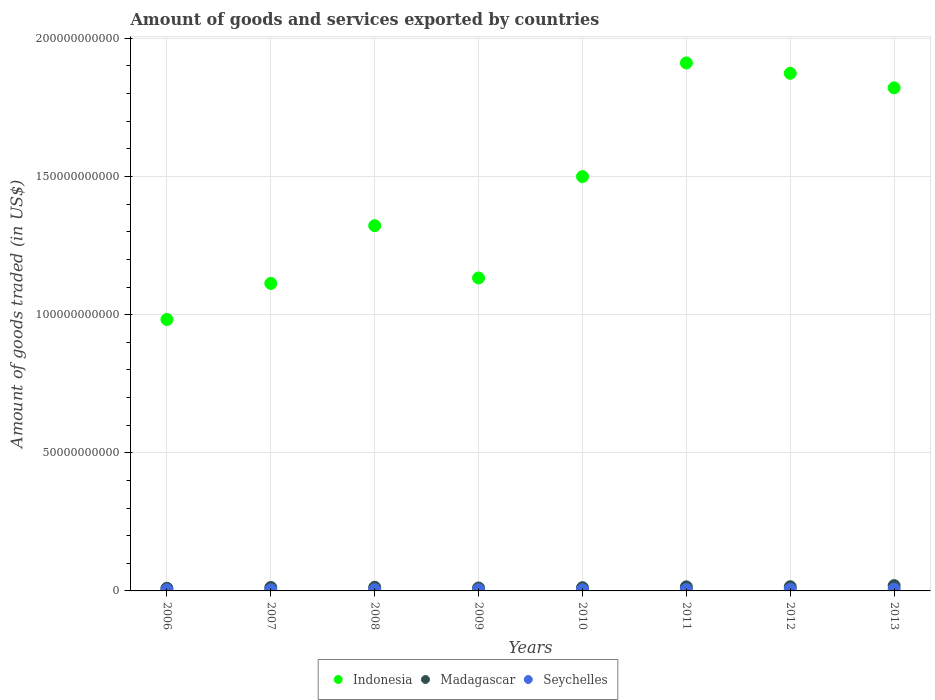How many different coloured dotlines are there?
Your answer should be very brief. 3. Is the number of dotlines equal to the number of legend labels?
Your response must be concise. Yes. What is the total amount of goods and services exported in Seychelles in 2011?
Offer a terse response. 4.77e+08. Across all years, what is the maximum total amount of goods and services exported in Madagascar?
Make the answer very short. 1.92e+09. Across all years, what is the minimum total amount of goods and services exported in Indonesia?
Give a very brief answer. 9.83e+1. In which year was the total amount of goods and services exported in Indonesia maximum?
Offer a terse response. 2011. What is the total total amount of goods and services exported in Madagascar in the graph?
Provide a short and direct response. 1.07e+1. What is the difference between the total amount of goods and services exported in Indonesia in 2007 and that in 2011?
Ensure brevity in your answer.  -7.98e+1. What is the difference between the total amount of goods and services exported in Madagascar in 2013 and the total amount of goods and services exported in Seychelles in 2012?
Provide a succinct answer. 1.36e+09. What is the average total amount of goods and services exported in Seychelles per year?
Provide a short and direct response. 4.69e+08. In the year 2007, what is the difference between the total amount of goods and services exported in Madagascar and total amount of goods and services exported in Indonesia?
Provide a short and direct response. -1.10e+11. What is the ratio of the total amount of goods and services exported in Indonesia in 2009 to that in 2013?
Provide a short and direct response. 0.62. Is the difference between the total amount of goods and services exported in Madagascar in 2006 and 2013 greater than the difference between the total amount of goods and services exported in Indonesia in 2006 and 2013?
Provide a short and direct response. Yes. What is the difference between the highest and the second highest total amount of goods and services exported in Seychelles?
Make the answer very short. 7.01e+07. What is the difference between the highest and the lowest total amount of goods and services exported in Madagascar?
Give a very brief answer. 9.57e+08. Is the sum of the total amount of goods and services exported in Indonesia in 2008 and 2010 greater than the maximum total amount of goods and services exported in Madagascar across all years?
Your response must be concise. Yes. Does the total amount of goods and services exported in Seychelles monotonically increase over the years?
Offer a terse response. No. Is the total amount of goods and services exported in Seychelles strictly greater than the total amount of goods and services exported in Indonesia over the years?
Make the answer very short. No. Is the total amount of goods and services exported in Indonesia strictly less than the total amount of goods and services exported in Madagascar over the years?
Ensure brevity in your answer.  No. How many years are there in the graph?
Ensure brevity in your answer.  8. What is the difference between two consecutive major ticks on the Y-axis?
Offer a very short reply. 5.00e+1. Where does the legend appear in the graph?
Provide a short and direct response. Bottom center. How are the legend labels stacked?
Your answer should be very brief. Horizontal. What is the title of the graph?
Ensure brevity in your answer.  Amount of goods and services exported by countries. What is the label or title of the X-axis?
Offer a very short reply. Years. What is the label or title of the Y-axis?
Ensure brevity in your answer.  Amount of goods traded (in US$). What is the Amount of goods traded (in US$) in Indonesia in 2006?
Keep it short and to the point. 9.83e+1. What is the Amount of goods traded (in US$) in Madagascar in 2006?
Provide a short and direct response. 9.66e+08. What is the Amount of goods traded (in US$) in Seychelles in 2006?
Your answer should be very brief. 4.19e+08. What is the Amount of goods traded (in US$) in Indonesia in 2007?
Provide a short and direct response. 1.11e+11. What is the Amount of goods traded (in US$) in Madagascar in 2007?
Keep it short and to the point. 1.25e+09. What is the Amount of goods traded (in US$) of Seychelles in 2007?
Your answer should be very brief. 3.98e+08. What is the Amount of goods traded (in US$) of Indonesia in 2008?
Your answer should be compact. 1.32e+11. What is the Amount of goods traded (in US$) of Madagascar in 2008?
Ensure brevity in your answer.  1.32e+09. What is the Amount of goods traded (in US$) in Seychelles in 2008?
Provide a short and direct response. 4.38e+08. What is the Amount of goods traded (in US$) of Indonesia in 2009?
Your answer should be compact. 1.13e+11. What is the Amount of goods traded (in US$) in Madagascar in 2009?
Offer a terse response. 1.06e+09. What is the Amount of goods traded (in US$) in Seychelles in 2009?
Offer a very short reply. 4.32e+08. What is the Amount of goods traded (in US$) of Indonesia in 2010?
Your response must be concise. 1.50e+11. What is the Amount of goods traded (in US$) in Madagascar in 2010?
Your answer should be very brief. 1.17e+09. What is the Amount of goods traded (in US$) of Seychelles in 2010?
Ensure brevity in your answer.  4.00e+08. What is the Amount of goods traded (in US$) in Indonesia in 2011?
Keep it short and to the point. 1.91e+11. What is the Amount of goods traded (in US$) of Madagascar in 2011?
Make the answer very short. 1.47e+09. What is the Amount of goods traded (in US$) in Seychelles in 2011?
Your answer should be compact. 4.77e+08. What is the Amount of goods traded (in US$) of Indonesia in 2012?
Your response must be concise. 1.87e+11. What is the Amount of goods traded (in US$) in Madagascar in 2012?
Your response must be concise. 1.52e+09. What is the Amount of goods traded (in US$) of Seychelles in 2012?
Your response must be concise. 5.59e+08. What is the Amount of goods traded (in US$) of Indonesia in 2013?
Your answer should be compact. 1.82e+11. What is the Amount of goods traded (in US$) of Madagascar in 2013?
Provide a short and direct response. 1.92e+09. What is the Amount of goods traded (in US$) of Seychelles in 2013?
Provide a succinct answer. 6.29e+08. Across all years, what is the maximum Amount of goods traded (in US$) in Indonesia?
Ensure brevity in your answer.  1.91e+11. Across all years, what is the maximum Amount of goods traded (in US$) of Madagascar?
Give a very brief answer. 1.92e+09. Across all years, what is the maximum Amount of goods traded (in US$) of Seychelles?
Give a very brief answer. 6.29e+08. Across all years, what is the minimum Amount of goods traded (in US$) in Indonesia?
Keep it short and to the point. 9.83e+1. Across all years, what is the minimum Amount of goods traded (in US$) in Madagascar?
Your answer should be compact. 9.66e+08. Across all years, what is the minimum Amount of goods traded (in US$) of Seychelles?
Make the answer very short. 3.98e+08. What is the total Amount of goods traded (in US$) in Indonesia in the graph?
Your answer should be very brief. 1.17e+12. What is the total Amount of goods traded (in US$) in Madagascar in the graph?
Your answer should be very brief. 1.07e+1. What is the total Amount of goods traded (in US$) of Seychelles in the graph?
Your answer should be very brief. 3.75e+09. What is the difference between the Amount of goods traded (in US$) of Indonesia in 2006 and that in 2007?
Make the answer very short. -1.31e+1. What is the difference between the Amount of goods traded (in US$) in Madagascar in 2006 and that in 2007?
Provide a succinct answer. -2.80e+08. What is the difference between the Amount of goods traded (in US$) in Seychelles in 2006 and that in 2007?
Your response must be concise. 2.16e+07. What is the difference between the Amount of goods traded (in US$) of Indonesia in 2006 and that in 2008?
Provide a succinct answer. -3.40e+1. What is the difference between the Amount of goods traded (in US$) in Madagascar in 2006 and that in 2008?
Offer a very short reply. -3.54e+08. What is the difference between the Amount of goods traded (in US$) of Seychelles in 2006 and that in 2008?
Give a very brief answer. -1.84e+07. What is the difference between the Amount of goods traded (in US$) of Indonesia in 2006 and that in 2009?
Make the answer very short. -1.50e+1. What is the difference between the Amount of goods traded (in US$) of Madagascar in 2006 and that in 2009?
Give a very brief answer. -9.53e+07. What is the difference between the Amount of goods traded (in US$) of Seychelles in 2006 and that in 2009?
Offer a very short reply. -1.26e+07. What is the difference between the Amount of goods traded (in US$) of Indonesia in 2006 and that in 2010?
Make the answer very short. -5.17e+1. What is the difference between the Amount of goods traded (in US$) in Madagascar in 2006 and that in 2010?
Provide a succinct answer. -2.01e+08. What is the difference between the Amount of goods traded (in US$) in Seychelles in 2006 and that in 2010?
Your answer should be compact. 1.90e+07. What is the difference between the Amount of goods traded (in US$) in Indonesia in 2006 and that in 2011?
Keep it short and to the point. -9.29e+1. What is the difference between the Amount of goods traded (in US$) in Madagascar in 2006 and that in 2011?
Offer a very short reply. -5.09e+08. What is the difference between the Amount of goods traded (in US$) of Seychelles in 2006 and that in 2011?
Ensure brevity in your answer.  -5.77e+07. What is the difference between the Amount of goods traded (in US$) in Indonesia in 2006 and that in 2012?
Offer a very short reply. -8.91e+1. What is the difference between the Amount of goods traded (in US$) of Madagascar in 2006 and that in 2012?
Offer a very short reply. -5.53e+08. What is the difference between the Amount of goods traded (in US$) of Seychelles in 2006 and that in 2012?
Keep it short and to the point. -1.40e+08. What is the difference between the Amount of goods traded (in US$) of Indonesia in 2006 and that in 2013?
Your answer should be very brief. -8.38e+1. What is the difference between the Amount of goods traded (in US$) in Madagascar in 2006 and that in 2013?
Offer a terse response. -9.57e+08. What is the difference between the Amount of goods traded (in US$) in Seychelles in 2006 and that in 2013?
Offer a very short reply. -2.10e+08. What is the difference between the Amount of goods traded (in US$) in Indonesia in 2007 and that in 2008?
Offer a very short reply. -2.09e+1. What is the difference between the Amount of goods traded (in US$) in Madagascar in 2007 and that in 2008?
Keep it short and to the point. -7.41e+07. What is the difference between the Amount of goods traded (in US$) of Seychelles in 2007 and that in 2008?
Offer a terse response. -4.01e+07. What is the difference between the Amount of goods traded (in US$) of Indonesia in 2007 and that in 2009?
Give a very brief answer. -1.96e+09. What is the difference between the Amount of goods traded (in US$) in Madagascar in 2007 and that in 2009?
Offer a terse response. 1.84e+08. What is the difference between the Amount of goods traded (in US$) of Seychelles in 2007 and that in 2009?
Offer a terse response. -3.42e+07. What is the difference between the Amount of goods traded (in US$) in Indonesia in 2007 and that in 2010?
Make the answer very short. -3.87e+1. What is the difference between the Amount of goods traded (in US$) of Madagascar in 2007 and that in 2010?
Provide a succinct answer. 7.86e+07. What is the difference between the Amount of goods traded (in US$) in Seychelles in 2007 and that in 2010?
Your response must be concise. -2.68e+06. What is the difference between the Amount of goods traded (in US$) in Indonesia in 2007 and that in 2011?
Make the answer very short. -7.98e+1. What is the difference between the Amount of goods traded (in US$) of Madagascar in 2007 and that in 2011?
Your answer should be very brief. -2.29e+08. What is the difference between the Amount of goods traded (in US$) in Seychelles in 2007 and that in 2011?
Your answer should be compact. -7.93e+07. What is the difference between the Amount of goods traded (in US$) of Indonesia in 2007 and that in 2012?
Offer a terse response. -7.60e+1. What is the difference between the Amount of goods traded (in US$) in Madagascar in 2007 and that in 2012?
Offer a very short reply. -2.73e+08. What is the difference between the Amount of goods traded (in US$) in Seychelles in 2007 and that in 2012?
Your answer should be very brief. -1.62e+08. What is the difference between the Amount of goods traded (in US$) of Indonesia in 2007 and that in 2013?
Your answer should be compact. -7.08e+1. What is the difference between the Amount of goods traded (in US$) in Madagascar in 2007 and that in 2013?
Give a very brief answer. -6.77e+08. What is the difference between the Amount of goods traded (in US$) of Seychelles in 2007 and that in 2013?
Provide a succinct answer. -2.32e+08. What is the difference between the Amount of goods traded (in US$) of Indonesia in 2008 and that in 2009?
Keep it short and to the point. 1.89e+1. What is the difference between the Amount of goods traded (in US$) in Madagascar in 2008 and that in 2009?
Your response must be concise. 2.59e+08. What is the difference between the Amount of goods traded (in US$) in Seychelles in 2008 and that in 2009?
Make the answer very short. 5.81e+06. What is the difference between the Amount of goods traded (in US$) in Indonesia in 2008 and that in 2010?
Keep it short and to the point. -1.78e+1. What is the difference between the Amount of goods traded (in US$) of Madagascar in 2008 and that in 2010?
Make the answer very short. 1.53e+08. What is the difference between the Amount of goods traded (in US$) of Seychelles in 2008 and that in 2010?
Make the answer very short. 3.74e+07. What is the difference between the Amount of goods traded (in US$) of Indonesia in 2008 and that in 2011?
Offer a very short reply. -5.89e+1. What is the difference between the Amount of goods traded (in US$) in Madagascar in 2008 and that in 2011?
Give a very brief answer. -1.55e+08. What is the difference between the Amount of goods traded (in US$) of Seychelles in 2008 and that in 2011?
Provide a short and direct response. -3.93e+07. What is the difference between the Amount of goods traded (in US$) of Indonesia in 2008 and that in 2012?
Offer a very short reply. -5.51e+1. What is the difference between the Amount of goods traded (in US$) in Madagascar in 2008 and that in 2012?
Make the answer very short. -1.99e+08. What is the difference between the Amount of goods traded (in US$) in Seychelles in 2008 and that in 2012?
Offer a very short reply. -1.22e+08. What is the difference between the Amount of goods traded (in US$) in Indonesia in 2008 and that in 2013?
Make the answer very short. -4.99e+1. What is the difference between the Amount of goods traded (in US$) in Madagascar in 2008 and that in 2013?
Offer a very short reply. -6.03e+08. What is the difference between the Amount of goods traded (in US$) in Seychelles in 2008 and that in 2013?
Your answer should be compact. -1.92e+08. What is the difference between the Amount of goods traded (in US$) in Indonesia in 2009 and that in 2010?
Offer a very short reply. -3.67e+1. What is the difference between the Amount of goods traded (in US$) of Madagascar in 2009 and that in 2010?
Offer a very short reply. -1.06e+08. What is the difference between the Amount of goods traded (in US$) of Seychelles in 2009 and that in 2010?
Ensure brevity in your answer.  3.16e+07. What is the difference between the Amount of goods traded (in US$) in Indonesia in 2009 and that in 2011?
Provide a succinct answer. -7.78e+1. What is the difference between the Amount of goods traded (in US$) of Madagascar in 2009 and that in 2011?
Offer a very short reply. -4.14e+08. What is the difference between the Amount of goods traded (in US$) of Seychelles in 2009 and that in 2011?
Your response must be concise. -4.51e+07. What is the difference between the Amount of goods traded (in US$) in Indonesia in 2009 and that in 2012?
Your response must be concise. -7.41e+1. What is the difference between the Amount of goods traded (in US$) of Madagascar in 2009 and that in 2012?
Provide a succinct answer. -4.58e+08. What is the difference between the Amount of goods traded (in US$) in Seychelles in 2009 and that in 2012?
Your answer should be compact. -1.27e+08. What is the difference between the Amount of goods traded (in US$) of Indonesia in 2009 and that in 2013?
Give a very brief answer. -6.88e+1. What is the difference between the Amount of goods traded (in US$) of Madagascar in 2009 and that in 2013?
Give a very brief answer. -8.61e+08. What is the difference between the Amount of goods traded (in US$) of Seychelles in 2009 and that in 2013?
Ensure brevity in your answer.  -1.97e+08. What is the difference between the Amount of goods traded (in US$) of Indonesia in 2010 and that in 2011?
Offer a very short reply. -4.11e+1. What is the difference between the Amount of goods traded (in US$) in Madagascar in 2010 and that in 2011?
Ensure brevity in your answer.  -3.08e+08. What is the difference between the Amount of goods traded (in US$) in Seychelles in 2010 and that in 2011?
Offer a terse response. -7.67e+07. What is the difference between the Amount of goods traded (in US$) of Indonesia in 2010 and that in 2012?
Offer a terse response. -3.74e+1. What is the difference between the Amount of goods traded (in US$) in Madagascar in 2010 and that in 2012?
Make the answer very short. -3.52e+08. What is the difference between the Amount of goods traded (in US$) in Seychelles in 2010 and that in 2012?
Your answer should be very brief. -1.59e+08. What is the difference between the Amount of goods traded (in US$) of Indonesia in 2010 and that in 2013?
Provide a succinct answer. -3.21e+1. What is the difference between the Amount of goods traded (in US$) in Madagascar in 2010 and that in 2013?
Offer a terse response. -7.55e+08. What is the difference between the Amount of goods traded (in US$) in Seychelles in 2010 and that in 2013?
Keep it short and to the point. -2.29e+08. What is the difference between the Amount of goods traded (in US$) of Indonesia in 2011 and that in 2012?
Give a very brief answer. 3.76e+09. What is the difference between the Amount of goods traded (in US$) in Madagascar in 2011 and that in 2012?
Give a very brief answer. -4.40e+07. What is the difference between the Amount of goods traded (in US$) in Seychelles in 2011 and that in 2012?
Provide a succinct answer. -8.22e+07. What is the difference between the Amount of goods traded (in US$) in Indonesia in 2011 and that in 2013?
Ensure brevity in your answer.  9.02e+09. What is the difference between the Amount of goods traded (in US$) in Madagascar in 2011 and that in 2013?
Make the answer very short. -4.48e+08. What is the difference between the Amount of goods traded (in US$) in Seychelles in 2011 and that in 2013?
Your answer should be compact. -1.52e+08. What is the difference between the Amount of goods traded (in US$) in Indonesia in 2012 and that in 2013?
Make the answer very short. 5.26e+09. What is the difference between the Amount of goods traded (in US$) in Madagascar in 2012 and that in 2013?
Ensure brevity in your answer.  -4.04e+08. What is the difference between the Amount of goods traded (in US$) of Seychelles in 2012 and that in 2013?
Provide a succinct answer. -7.01e+07. What is the difference between the Amount of goods traded (in US$) in Indonesia in 2006 and the Amount of goods traded (in US$) in Madagascar in 2007?
Offer a terse response. 9.70e+1. What is the difference between the Amount of goods traded (in US$) of Indonesia in 2006 and the Amount of goods traded (in US$) of Seychelles in 2007?
Provide a short and direct response. 9.79e+1. What is the difference between the Amount of goods traded (in US$) of Madagascar in 2006 and the Amount of goods traded (in US$) of Seychelles in 2007?
Keep it short and to the point. 5.68e+08. What is the difference between the Amount of goods traded (in US$) in Indonesia in 2006 and the Amount of goods traded (in US$) in Madagascar in 2008?
Your answer should be very brief. 9.69e+1. What is the difference between the Amount of goods traded (in US$) in Indonesia in 2006 and the Amount of goods traded (in US$) in Seychelles in 2008?
Your answer should be compact. 9.78e+1. What is the difference between the Amount of goods traded (in US$) in Madagascar in 2006 and the Amount of goods traded (in US$) in Seychelles in 2008?
Provide a short and direct response. 5.28e+08. What is the difference between the Amount of goods traded (in US$) of Indonesia in 2006 and the Amount of goods traded (in US$) of Madagascar in 2009?
Give a very brief answer. 9.72e+1. What is the difference between the Amount of goods traded (in US$) in Indonesia in 2006 and the Amount of goods traded (in US$) in Seychelles in 2009?
Keep it short and to the point. 9.78e+1. What is the difference between the Amount of goods traded (in US$) of Madagascar in 2006 and the Amount of goods traded (in US$) of Seychelles in 2009?
Your answer should be very brief. 5.34e+08. What is the difference between the Amount of goods traded (in US$) in Indonesia in 2006 and the Amount of goods traded (in US$) in Madagascar in 2010?
Provide a short and direct response. 9.71e+1. What is the difference between the Amount of goods traded (in US$) of Indonesia in 2006 and the Amount of goods traded (in US$) of Seychelles in 2010?
Offer a terse response. 9.79e+1. What is the difference between the Amount of goods traded (in US$) of Madagascar in 2006 and the Amount of goods traded (in US$) of Seychelles in 2010?
Offer a terse response. 5.65e+08. What is the difference between the Amount of goods traded (in US$) of Indonesia in 2006 and the Amount of goods traded (in US$) of Madagascar in 2011?
Offer a terse response. 9.68e+1. What is the difference between the Amount of goods traded (in US$) of Indonesia in 2006 and the Amount of goods traded (in US$) of Seychelles in 2011?
Provide a short and direct response. 9.78e+1. What is the difference between the Amount of goods traded (in US$) of Madagascar in 2006 and the Amount of goods traded (in US$) of Seychelles in 2011?
Your answer should be compact. 4.89e+08. What is the difference between the Amount of goods traded (in US$) of Indonesia in 2006 and the Amount of goods traded (in US$) of Madagascar in 2012?
Offer a terse response. 9.67e+1. What is the difference between the Amount of goods traded (in US$) in Indonesia in 2006 and the Amount of goods traded (in US$) in Seychelles in 2012?
Your answer should be compact. 9.77e+1. What is the difference between the Amount of goods traded (in US$) in Madagascar in 2006 and the Amount of goods traded (in US$) in Seychelles in 2012?
Your response must be concise. 4.06e+08. What is the difference between the Amount of goods traded (in US$) in Indonesia in 2006 and the Amount of goods traded (in US$) in Madagascar in 2013?
Your answer should be compact. 9.63e+1. What is the difference between the Amount of goods traded (in US$) in Indonesia in 2006 and the Amount of goods traded (in US$) in Seychelles in 2013?
Make the answer very short. 9.76e+1. What is the difference between the Amount of goods traded (in US$) in Madagascar in 2006 and the Amount of goods traded (in US$) in Seychelles in 2013?
Ensure brevity in your answer.  3.36e+08. What is the difference between the Amount of goods traded (in US$) of Indonesia in 2007 and the Amount of goods traded (in US$) of Madagascar in 2008?
Your answer should be very brief. 1.10e+11. What is the difference between the Amount of goods traded (in US$) in Indonesia in 2007 and the Amount of goods traded (in US$) in Seychelles in 2008?
Ensure brevity in your answer.  1.11e+11. What is the difference between the Amount of goods traded (in US$) of Madagascar in 2007 and the Amount of goods traded (in US$) of Seychelles in 2008?
Make the answer very short. 8.08e+08. What is the difference between the Amount of goods traded (in US$) in Indonesia in 2007 and the Amount of goods traded (in US$) in Madagascar in 2009?
Your answer should be very brief. 1.10e+11. What is the difference between the Amount of goods traded (in US$) of Indonesia in 2007 and the Amount of goods traded (in US$) of Seychelles in 2009?
Give a very brief answer. 1.11e+11. What is the difference between the Amount of goods traded (in US$) of Madagascar in 2007 and the Amount of goods traded (in US$) of Seychelles in 2009?
Provide a succinct answer. 8.14e+08. What is the difference between the Amount of goods traded (in US$) in Indonesia in 2007 and the Amount of goods traded (in US$) in Madagascar in 2010?
Your answer should be compact. 1.10e+11. What is the difference between the Amount of goods traded (in US$) in Indonesia in 2007 and the Amount of goods traded (in US$) in Seychelles in 2010?
Make the answer very short. 1.11e+11. What is the difference between the Amount of goods traded (in US$) in Madagascar in 2007 and the Amount of goods traded (in US$) in Seychelles in 2010?
Your answer should be very brief. 8.45e+08. What is the difference between the Amount of goods traded (in US$) of Indonesia in 2007 and the Amount of goods traded (in US$) of Madagascar in 2011?
Your response must be concise. 1.10e+11. What is the difference between the Amount of goods traded (in US$) of Indonesia in 2007 and the Amount of goods traded (in US$) of Seychelles in 2011?
Offer a very short reply. 1.11e+11. What is the difference between the Amount of goods traded (in US$) in Madagascar in 2007 and the Amount of goods traded (in US$) in Seychelles in 2011?
Offer a very short reply. 7.68e+08. What is the difference between the Amount of goods traded (in US$) of Indonesia in 2007 and the Amount of goods traded (in US$) of Madagascar in 2012?
Your response must be concise. 1.10e+11. What is the difference between the Amount of goods traded (in US$) of Indonesia in 2007 and the Amount of goods traded (in US$) of Seychelles in 2012?
Provide a succinct answer. 1.11e+11. What is the difference between the Amount of goods traded (in US$) in Madagascar in 2007 and the Amount of goods traded (in US$) in Seychelles in 2012?
Provide a succinct answer. 6.86e+08. What is the difference between the Amount of goods traded (in US$) of Indonesia in 2007 and the Amount of goods traded (in US$) of Madagascar in 2013?
Offer a terse response. 1.09e+11. What is the difference between the Amount of goods traded (in US$) of Indonesia in 2007 and the Amount of goods traded (in US$) of Seychelles in 2013?
Offer a very short reply. 1.11e+11. What is the difference between the Amount of goods traded (in US$) in Madagascar in 2007 and the Amount of goods traded (in US$) in Seychelles in 2013?
Provide a succinct answer. 6.16e+08. What is the difference between the Amount of goods traded (in US$) of Indonesia in 2008 and the Amount of goods traded (in US$) of Madagascar in 2009?
Give a very brief answer. 1.31e+11. What is the difference between the Amount of goods traded (in US$) in Indonesia in 2008 and the Amount of goods traded (in US$) in Seychelles in 2009?
Ensure brevity in your answer.  1.32e+11. What is the difference between the Amount of goods traded (in US$) in Madagascar in 2008 and the Amount of goods traded (in US$) in Seychelles in 2009?
Your answer should be compact. 8.88e+08. What is the difference between the Amount of goods traded (in US$) in Indonesia in 2008 and the Amount of goods traded (in US$) in Madagascar in 2010?
Make the answer very short. 1.31e+11. What is the difference between the Amount of goods traded (in US$) of Indonesia in 2008 and the Amount of goods traded (in US$) of Seychelles in 2010?
Your answer should be compact. 1.32e+11. What is the difference between the Amount of goods traded (in US$) in Madagascar in 2008 and the Amount of goods traded (in US$) in Seychelles in 2010?
Offer a very short reply. 9.19e+08. What is the difference between the Amount of goods traded (in US$) of Indonesia in 2008 and the Amount of goods traded (in US$) of Madagascar in 2011?
Provide a succinct answer. 1.31e+11. What is the difference between the Amount of goods traded (in US$) of Indonesia in 2008 and the Amount of goods traded (in US$) of Seychelles in 2011?
Provide a short and direct response. 1.32e+11. What is the difference between the Amount of goods traded (in US$) of Madagascar in 2008 and the Amount of goods traded (in US$) of Seychelles in 2011?
Your response must be concise. 8.42e+08. What is the difference between the Amount of goods traded (in US$) of Indonesia in 2008 and the Amount of goods traded (in US$) of Madagascar in 2012?
Provide a succinct answer. 1.31e+11. What is the difference between the Amount of goods traded (in US$) of Indonesia in 2008 and the Amount of goods traded (in US$) of Seychelles in 2012?
Offer a terse response. 1.32e+11. What is the difference between the Amount of goods traded (in US$) of Madagascar in 2008 and the Amount of goods traded (in US$) of Seychelles in 2012?
Provide a short and direct response. 7.60e+08. What is the difference between the Amount of goods traded (in US$) in Indonesia in 2008 and the Amount of goods traded (in US$) in Madagascar in 2013?
Your response must be concise. 1.30e+11. What is the difference between the Amount of goods traded (in US$) of Indonesia in 2008 and the Amount of goods traded (in US$) of Seychelles in 2013?
Offer a terse response. 1.32e+11. What is the difference between the Amount of goods traded (in US$) of Madagascar in 2008 and the Amount of goods traded (in US$) of Seychelles in 2013?
Make the answer very short. 6.90e+08. What is the difference between the Amount of goods traded (in US$) in Indonesia in 2009 and the Amount of goods traded (in US$) in Madagascar in 2010?
Provide a succinct answer. 1.12e+11. What is the difference between the Amount of goods traded (in US$) of Indonesia in 2009 and the Amount of goods traded (in US$) of Seychelles in 2010?
Your response must be concise. 1.13e+11. What is the difference between the Amount of goods traded (in US$) of Madagascar in 2009 and the Amount of goods traded (in US$) of Seychelles in 2010?
Keep it short and to the point. 6.61e+08. What is the difference between the Amount of goods traded (in US$) of Indonesia in 2009 and the Amount of goods traded (in US$) of Madagascar in 2011?
Your response must be concise. 1.12e+11. What is the difference between the Amount of goods traded (in US$) in Indonesia in 2009 and the Amount of goods traded (in US$) in Seychelles in 2011?
Provide a short and direct response. 1.13e+11. What is the difference between the Amount of goods traded (in US$) of Madagascar in 2009 and the Amount of goods traded (in US$) of Seychelles in 2011?
Offer a very short reply. 5.84e+08. What is the difference between the Amount of goods traded (in US$) in Indonesia in 2009 and the Amount of goods traded (in US$) in Madagascar in 2012?
Provide a short and direct response. 1.12e+11. What is the difference between the Amount of goods traded (in US$) of Indonesia in 2009 and the Amount of goods traded (in US$) of Seychelles in 2012?
Offer a terse response. 1.13e+11. What is the difference between the Amount of goods traded (in US$) in Madagascar in 2009 and the Amount of goods traded (in US$) in Seychelles in 2012?
Give a very brief answer. 5.02e+08. What is the difference between the Amount of goods traded (in US$) of Indonesia in 2009 and the Amount of goods traded (in US$) of Madagascar in 2013?
Give a very brief answer. 1.11e+11. What is the difference between the Amount of goods traded (in US$) of Indonesia in 2009 and the Amount of goods traded (in US$) of Seychelles in 2013?
Your response must be concise. 1.13e+11. What is the difference between the Amount of goods traded (in US$) in Madagascar in 2009 and the Amount of goods traded (in US$) in Seychelles in 2013?
Your answer should be very brief. 4.32e+08. What is the difference between the Amount of goods traded (in US$) in Indonesia in 2010 and the Amount of goods traded (in US$) in Madagascar in 2011?
Keep it short and to the point. 1.48e+11. What is the difference between the Amount of goods traded (in US$) of Indonesia in 2010 and the Amount of goods traded (in US$) of Seychelles in 2011?
Your answer should be compact. 1.49e+11. What is the difference between the Amount of goods traded (in US$) in Madagascar in 2010 and the Amount of goods traded (in US$) in Seychelles in 2011?
Give a very brief answer. 6.90e+08. What is the difference between the Amount of goods traded (in US$) of Indonesia in 2010 and the Amount of goods traded (in US$) of Madagascar in 2012?
Provide a short and direct response. 1.48e+11. What is the difference between the Amount of goods traded (in US$) of Indonesia in 2010 and the Amount of goods traded (in US$) of Seychelles in 2012?
Keep it short and to the point. 1.49e+11. What is the difference between the Amount of goods traded (in US$) of Madagascar in 2010 and the Amount of goods traded (in US$) of Seychelles in 2012?
Your answer should be compact. 6.08e+08. What is the difference between the Amount of goods traded (in US$) of Indonesia in 2010 and the Amount of goods traded (in US$) of Madagascar in 2013?
Ensure brevity in your answer.  1.48e+11. What is the difference between the Amount of goods traded (in US$) of Indonesia in 2010 and the Amount of goods traded (in US$) of Seychelles in 2013?
Offer a very short reply. 1.49e+11. What is the difference between the Amount of goods traded (in US$) of Madagascar in 2010 and the Amount of goods traded (in US$) of Seychelles in 2013?
Offer a terse response. 5.37e+08. What is the difference between the Amount of goods traded (in US$) in Indonesia in 2011 and the Amount of goods traded (in US$) in Madagascar in 2012?
Your answer should be compact. 1.90e+11. What is the difference between the Amount of goods traded (in US$) in Indonesia in 2011 and the Amount of goods traded (in US$) in Seychelles in 2012?
Offer a terse response. 1.91e+11. What is the difference between the Amount of goods traded (in US$) of Madagascar in 2011 and the Amount of goods traded (in US$) of Seychelles in 2012?
Provide a succinct answer. 9.15e+08. What is the difference between the Amount of goods traded (in US$) in Indonesia in 2011 and the Amount of goods traded (in US$) in Madagascar in 2013?
Ensure brevity in your answer.  1.89e+11. What is the difference between the Amount of goods traded (in US$) in Indonesia in 2011 and the Amount of goods traded (in US$) in Seychelles in 2013?
Keep it short and to the point. 1.90e+11. What is the difference between the Amount of goods traded (in US$) in Madagascar in 2011 and the Amount of goods traded (in US$) in Seychelles in 2013?
Provide a short and direct response. 8.45e+08. What is the difference between the Amount of goods traded (in US$) in Indonesia in 2012 and the Amount of goods traded (in US$) in Madagascar in 2013?
Your answer should be compact. 1.85e+11. What is the difference between the Amount of goods traded (in US$) of Indonesia in 2012 and the Amount of goods traded (in US$) of Seychelles in 2013?
Provide a succinct answer. 1.87e+11. What is the difference between the Amount of goods traded (in US$) of Madagascar in 2012 and the Amount of goods traded (in US$) of Seychelles in 2013?
Keep it short and to the point. 8.89e+08. What is the average Amount of goods traded (in US$) of Indonesia per year?
Your answer should be very brief. 1.46e+11. What is the average Amount of goods traded (in US$) of Madagascar per year?
Provide a succinct answer. 1.33e+09. What is the average Amount of goods traded (in US$) of Seychelles per year?
Offer a terse response. 4.69e+08. In the year 2006, what is the difference between the Amount of goods traded (in US$) of Indonesia and Amount of goods traded (in US$) of Madagascar?
Provide a short and direct response. 9.73e+1. In the year 2006, what is the difference between the Amount of goods traded (in US$) of Indonesia and Amount of goods traded (in US$) of Seychelles?
Make the answer very short. 9.78e+1. In the year 2006, what is the difference between the Amount of goods traded (in US$) of Madagascar and Amount of goods traded (in US$) of Seychelles?
Your response must be concise. 5.46e+08. In the year 2007, what is the difference between the Amount of goods traded (in US$) in Indonesia and Amount of goods traded (in US$) in Madagascar?
Offer a terse response. 1.10e+11. In the year 2007, what is the difference between the Amount of goods traded (in US$) in Indonesia and Amount of goods traded (in US$) in Seychelles?
Provide a short and direct response. 1.11e+11. In the year 2007, what is the difference between the Amount of goods traded (in US$) in Madagascar and Amount of goods traded (in US$) in Seychelles?
Offer a very short reply. 8.48e+08. In the year 2008, what is the difference between the Amount of goods traded (in US$) of Indonesia and Amount of goods traded (in US$) of Madagascar?
Give a very brief answer. 1.31e+11. In the year 2008, what is the difference between the Amount of goods traded (in US$) in Indonesia and Amount of goods traded (in US$) in Seychelles?
Your response must be concise. 1.32e+11. In the year 2008, what is the difference between the Amount of goods traded (in US$) in Madagascar and Amount of goods traded (in US$) in Seychelles?
Make the answer very short. 8.82e+08. In the year 2009, what is the difference between the Amount of goods traded (in US$) of Indonesia and Amount of goods traded (in US$) of Madagascar?
Provide a succinct answer. 1.12e+11. In the year 2009, what is the difference between the Amount of goods traded (in US$) of Indonesia and Amount of goods traded (in US$) of Seychelles?
Keep it short and to the point. 1.13e+11. In the year 2009, what is the difference between the Amount of goods traded (in US$) in Madagascar and Amount of goods traded (in US$) in Seychelles?
Provide a succinct answer. 6.29e+08. In the year 2010, what is the difference between the Amount of goods traded (in US$) of Indonesia and Amount of goods traded (in US$) of Madagascar?
Provide a short and direct response. 1.49e+11. In the year 2010, what is the difference between the Amount of goods traded (in US$) in Indonesia and Amount of goods traded (in US$) in Seychelles?
Offer a very short reply. 1.50e+11. In the year 2010, what is the difference between the Amount of goods traded (in US$) in Madagascar and Amount of goods traded (in US$) in Seychelles?
Ensure brevity in your answer.  7.66e+08. In the year 2011, what is the difference between the Amount of goods traded (in US$) of Indonesia and Amount of goods traded (in US$) of Madagascar?
Your answer should be very brief. 1.90e+11. In the year 2011, what is the difference between the Amount of goods traded (in US$) of Indonesia and Amount of goods traded (in US$) of Seychelles?
Your answer should be compact. 1.91e+11. In the year 2011, what is the difference between the Amount of goods traded (in US$) of Madagascar and Amount of goods traded (in US$) of Seychelles?
Ensure brevity in your answer.  9.98e+08. In the year 2012, what is the difference between the Amount of goods traded (in US$) in Indonesia and Amount of goods traded (in US$) in Madagascar?
Offer a terse response. 1.86e+11. In the year 2012, what is the difference between the Amount of goods traded (in US$) of Indonesia and Amount of goods traded (in US$) of Seychelles?
Your response must be concise. 1.87e+11. In the year 2012, what is the difference between the Amount of goods traded (in US$) of Madagascar and Amount of goods traded (in US$) of Seychelles?
Make the answer very short. 9.59e+08. In the year 2013, what is the difference between the Amount of goods traded (in US$) in Indonesia and Amount of goods traded (in US$) in Madagascar?
Give a very brief answer. 1.80e+11. In the year 2013, what is the difference between the Amount of goods traded (in US$) in Indonesia and Amount of goods traded (in US$) in Seychelles?
Offer a terse response. 1.81e+11. In the year 2013, what is the difference between the Amount of goods traded (in US$) of Madagascar and Amount of goods traded (in US$) of Seychelles?
Provide a succinct answer. 1.29e+09. What is the ratio of the Amount of goods traded (in US$) of Indonesia in 2006 to that in 2007?
Your response must be concise. 0.88. What is the ratio of the Amount of goods traded (in US$) of Madagascar in 2006 to that in 2007?
Make the answer very short. 0.78. What is the ratio of the Amount of goods traded (in US$) of Seychelles in 2006 to that in 2007?
Ensure brevity in your answer.  1.05. What is the ratio of the Amount of goods traded (in US$) in Indonesia in 2006 to that in 2008?
Make the answer very short. 0.74. What is the ratio of the Amount of goods traded (in US$) of Madagascar in 2006 to that in 2008?
Give a very brief answer. 0.73. What is the ratio of the Amount of goods traded (in US$) in Seychelles in 2006 to that in 2008?
Your answer should be compact. 0.96. What is the ratio of the Amount of goods traded (in US$) in Indonesia in 2006 to that in 2009?
Provide a succinct answer. 0.87. What is the ratio of the Amount of goods traded (in US$) in Madagascar in 2006 to that in 2009?
Your answer should be compact. 0.91. What is the ratio of the Amount of goods traded (in US$) in Seychelles in 2006 to that in 2009?
Offer a terse response. 0.97. What is the ratio of the Amount of goods traded (in US$) of Indonesia in 2006 to that in 2010?
Give a very brief answer. 0.66. What is the ratio of the Amount of goods traded (in US$) of Madagascar in 2006 to that in 2010?
Make the answer very short. 0.83. What is the ratio of the Amount of goods traded (in US$) in Seychelles in 2006 to that in 2010?
Ensure brevity in your answer.  1.05. What is the ratio of the Amount of goods traded (in US$) of Indonesia in 2006 to that in 2011?
Your response must be concise. 0.51. What is the ratio of the Amount of goods traded (in US$) of Madagascar in 2006 to that in 2011?
Offer a terse response. 0.65. What is the ratio of the Amount of goods traded (in US$) of Seychelles in 2006 to that in 2011?
Your response must be concise. 0.88. What is the ratio of the Amount of goods traded (in US$) of Indonesia in 2006 to that in 2012?
Provide a succinct answer. 0.52. What is the ratio of the Amount of goods traded (in US$) in Madagascar in 2006 to that in 2012?
Offer a very short reply. 0.64. What is the ratio of the Amount of goods traded (in US$) in Seychelles in 2006 to that in 2012?
Keep it short and to the point. 0.75. What is the ratio of the Amount of goods traded (in US$) of Indonesia in 2006 to that in 2013?
Ensure brevity in your answer.  0.54. What is the ratio of the Amount of goods traded (in US$) of Madagascar in 2006 to that in 2013?
Ensure brevity in your answer.  0.5. What is the ratio of the Amount of goods traded (in US$) in Seychelles in 2006 to that in 2013?
Your answer should be very brief. 0.67. What is the ratio of the Amount of goods traded (in US$) of Indonesia in 2007 to that in 2008?
Your response must be concise. 0.84. What is the ratio of the Amount of goods traded (in US$) of Madagascar in 2007 to that in 2008?
Ensure brevity in your answer.  0.94. What is the ratio of the Amount of goods traded (in US$) of Seychelles in 2007 to that in 2008?
Ensure brevity in your answer.  0.91. What is the ratio of the Amount of goods traded (in US$) of Indonesia in 2007 to that in 2009?
Provide a succinct answer. 0.98. What is the ratio of the Amount of goods traded (in US$) of Madagascar in 2007 to that in 2009?
Keep it short and to the point. 1.17. What is the ratio of the Amount of goods traded (in US$) of Seychelles in 2007 to that in 2009?
Give a very brief answer. 0.92. What is the ratio of the Amount of goods traded (in US$) of Indonesia in 2007 to that in 2010?
Your response must be concise. 0.74. What is the ratio of the Amount of goods traded (in US$) of Madagascar in 2007 to that in 2010?
Provide a short and direct response. 1.07. What is the ratio of the Amount of goods traded (in US$) of Seychelles in 2007 to that in 2010?
Offer a very short reply. 0.99. What is the ratio of the Amount of goods traded (in US$) of Indonesia in 2007 to that in 2011?
Your answer should be compact. 0.58. What is the ratio of the Amount of goods traded (in US$) in Madagascar in 2007 to that in 2011?
Offer a terse response. 0.84. What is the ratio of the Amount of goods traded (in US$) of Seychelles in 2007 to that in 2011?
Provide a short and direct response. 0.83. What is the ratio of the Amount of goods traded (in US$) of Indonesia in 2007 to that in 2012?
Offer a terse response. 0.59. What is the ratio of the Amount of goods traded (in US$) of Madagascar in 2007 to that in 2012?
Give a very brief answer. 0.82. What is the ratio of the Amount of goods traded (in US$) in Seychelles in 2007 to that in 2012?
Offer a very short reply. 0.71. What is the ratio of the Amount of goods traded (in US$) in Indonesia in 2007 to that in 2013?
Give a very brief answer. 0.61. What is the ratio of the Amount of goods traded (in US$) in Madagascar in 2007 to that in 2013?
Your answer should be very brief. 0.65. What is the ratio of the Amount of goods traded (in US$) in Seychelles in 2007 to that in 2013?
Provide a short and direct response. 0.63. What is the ratio of the Amount of goods traded (in US$) in Indonesia in 2008 to that in 2009?
Offer a very short reply. 1.17. What is the ratio of the Amount of goods traded (in US$) of Madagascar in 2008 to that in 2009?
Your response must be concise. 1.24. What is the ratio of the Amount of goods traded (in US$) of Seychelles in 2008 to that in 2009?
Your answer should be very brief. 1.01. What is the ratio of the Amount of goods traded (in US$) of Indonesia in 2008 to that in 2010?
Provide a succinct answer. 0.88. What is the ratio of the Amount of goods traded (in US$) of Madagascar in 2008 to that in 2010?
Ensure brevity in your answer.  1.13. What is the ratio of the Amount of goods traded (in US$) in Seychelles in 2008 to that in 2010?
Provide a short and direct response. 1.09. What is the ratio of the Amount of goods traded (in US$) in Indonesia in 2008 to that in 2011?
Your answer should be compact. 0.69. What is the ratio of the Amount of goods traded (in US$) of Madagascar in 2008 to that in 2011?
Your answer should be compact. 0.89. What is the ratio of the Amount of goods traded (in US$) in Seychelles in 2008 to that in 2011?
Provide a succinct answer. 0.92. What is the ratio of the Amount of goods traded (in US$) in Indonesia in 2008 to that in 2012?
Offer a terse response. 0.71. What is the ratio of the Amount of goods traded (in US$) of Madagascar in 2008 to that in 2012?
Make the answer very short. 0.87. What is the ratio of the Amount of goods traded (in US$) in Seychelles in 2008 to that in 2012?
Provide a short and direct response. 0.78. What is the ratio of the Amount of goods traded (in US$) of Indonesia in 2008 to that in 2013?
Give a very brief answer. 0.73. What is the ratio of the Amount of goods traded (in US$) of Madagascar in 2008 to that in 2013?
Keep it short and to the point. 0.69. What is the ratio of the Amount of goods traded (in US$) in Seychelles in 2008 to that in 2013?
Provide a succinct answer. 0.7. What is the ratio of the Amount of goods traded (in US$) in Indonesia in 2009 to that in 2010?
Provide a short and direct response. 0.76. What is the ratio of the Amount of goods traded (in US$) of Madagascar in 2009 to that in 2010?
Your answer should be compact. 0.91. What is the ratio of the Amount of goods traded (in US$) of Seychelles in 2009 to that in 2010?
Provide a succinct answer. 1.08. What is the ratio of the Amount of goods traded (in US$) in Indonesia in 2009 to that in 2011?
Keep it short and to the point. 0.59. What is the ratio of the Amount of goods traded (in US$) in Madagascar in 2009 to that in 2011?
Offer a very short reply. 0.72. What is the ratio of the Amount of goods traded (in US$) of Seychelles in 2009 to that in 2011?
Your answer should be very brief. 0.91. What is the ratio of the Amount of goods traded (in US$) of Indonesia in 2009 to that in 2012?
Make the answer very short. 0.6. What is the ratio of the Amount of goods traded (in US$) of Madagascar in 2009 to that in 2012?
Provide a succinct answer. 0.7. What is the ratio of the Amount of goods traded (in US$) of Seychelles in 2009 to that in 2012?
Provide a succinct answer. 0.77. What is the ratio of the Amount of goods traded (in US$) in Indonesia in 2009 to that in 2013?
Offer a terse response. 0.62. What is the ratio of the Amount of goods traded (in US$) in Madagascar in 2009 to that in 2013?
Provide a short and direct response. 0.55. What is the ratio of the Amount of goods traded (in US$) of Seychelles in 2009 to that in 2013?
Your answer should be compact. 0.69. What is the ratio of the Amount of goods traded (in US$) of Indonesia in 2010 to that in 2011?
Provide a succinct answer. 0.78. What is the ratio of the Amount of goods traded (in US$) in Madagascar in 2010 to that in 2011?
Your response must be concise. 0.79. What is the ratio of the Amount of goods traded (in US$) in Seychelles in 2010 to that in 2011?
Ensure brevity in your answer.  0.84. What is the ratio of the Amount of goods traded (in US$) of Indonesia in 2010 to that in 2012?
Offer a very short reply. 0.8. What is the ratio of the Amount of goods traded (in US$) in Madagascar in 2010 to that in 2012?
Give a very brief answer. 0.77. What is the ratio of the Amount of goods traded (in US$) in Seychelles in 2010 to that in 2012?
Make the answer very short. 0.72. What is the ratio of the Amount of goods traded (in US$) of Indonesia in 2010 to that in 2013?
Offer a very short reply. 0.82. What is the ratio of the Amount of goods traded (in US$) in Madagascar in 2010 to that in 2013?
Make the answer very short. 0.61. What is the ratio of the Amount of goods traded (in US$) in Seychelles in 2010 to that in 2013?
Keep it short and to the point. 0.64. What is the ratio of the Amount of goods traded (in US$) in Indonesia in 2011 to that in 2012?
Your answer should be very brief. 1.02. What is the ratio of the Amount of goods traded (in US$) of Seychelles in 2011 to that in 2012?
Your answer should be very brief. 0.85. What is the ratio of the Amount of goods traded (in US$) in Indonesia in 2011 to that in 2013?
Ensure brevity in your answer.  1.05. What is the ratio of the Amount of goods traded (in US$) of Madagascar in 2011 to that in 2013?
Offer a very short reply. 0.77. What is the ratio of the Amount of goods traded (in US$) of Seychelles in 2011 to that in 2013?
Your answer should be compact. 0.76. What is the ratio of the Amount of goods traded (in US$) in Indonesia in 2012 to that in 2013?
Keep it short and to the point. 1.03. What is the ratio of the Amount of goods traded (in US$) of Madagascar in 2012 to that in 2013?
Offer a terse response. 0.79. What is the ratio of the Amount of goods traded (in US$) of Seychelles in 2012 to that in 2013?
Make the answer very short. 0.89. What is the difference between the highest and the second highest Amount of goods traded (in US$) in Indonesia?
Your response must be concise. 3.76e+09. What is the difference between the highest and the second highest Amount of goods traded (in US$) of Madagascar?
Your answer should be compact. 4.04e+08. What is the difference between the highest and the second highest Amount of goods traded (in US$) in Seychelles?
Provide a succinct answer. 7.01e+07. What is the difference between the highest and the lowest Amount of goods traded (in US$) in Indonesia?
Your response must be concise. 9.29e+1. What is the difference between the highest and the lowest Amount of goods traded (in US$) of Madagascar?
Offer a terse response. 9.57e+08. What is the difference between the highest and the lowest Amount of goods traded (in US$) in Seychelles?
Offer a terse response. 2.32e+08. 